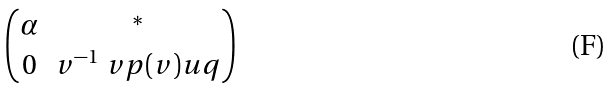Convert formula to latex. <formula><loc_0><loc_0><loc_500><loc_500>\begin{pmatrix} \alpha & ^ { * } \\ 0 & v ^ { - 1 } \ v p ( v ) u q \end{pmatrix}</formula> 